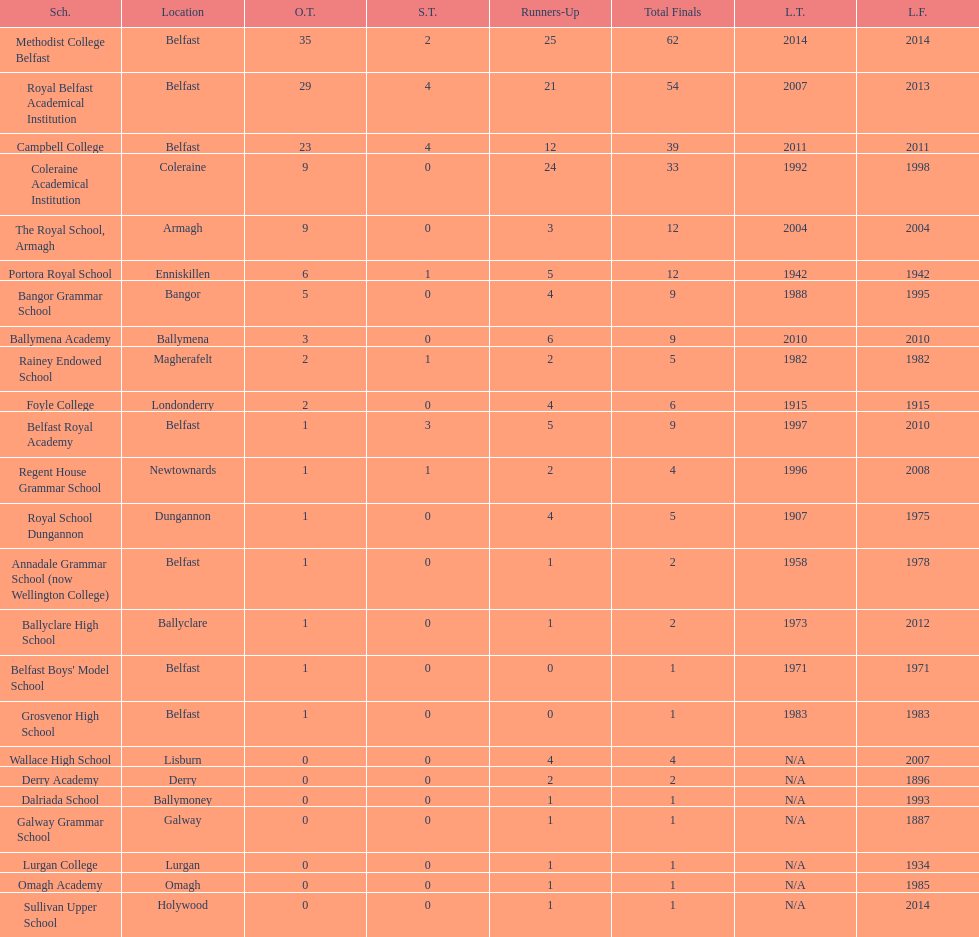How many schools had above 5 outright titles? 6. 